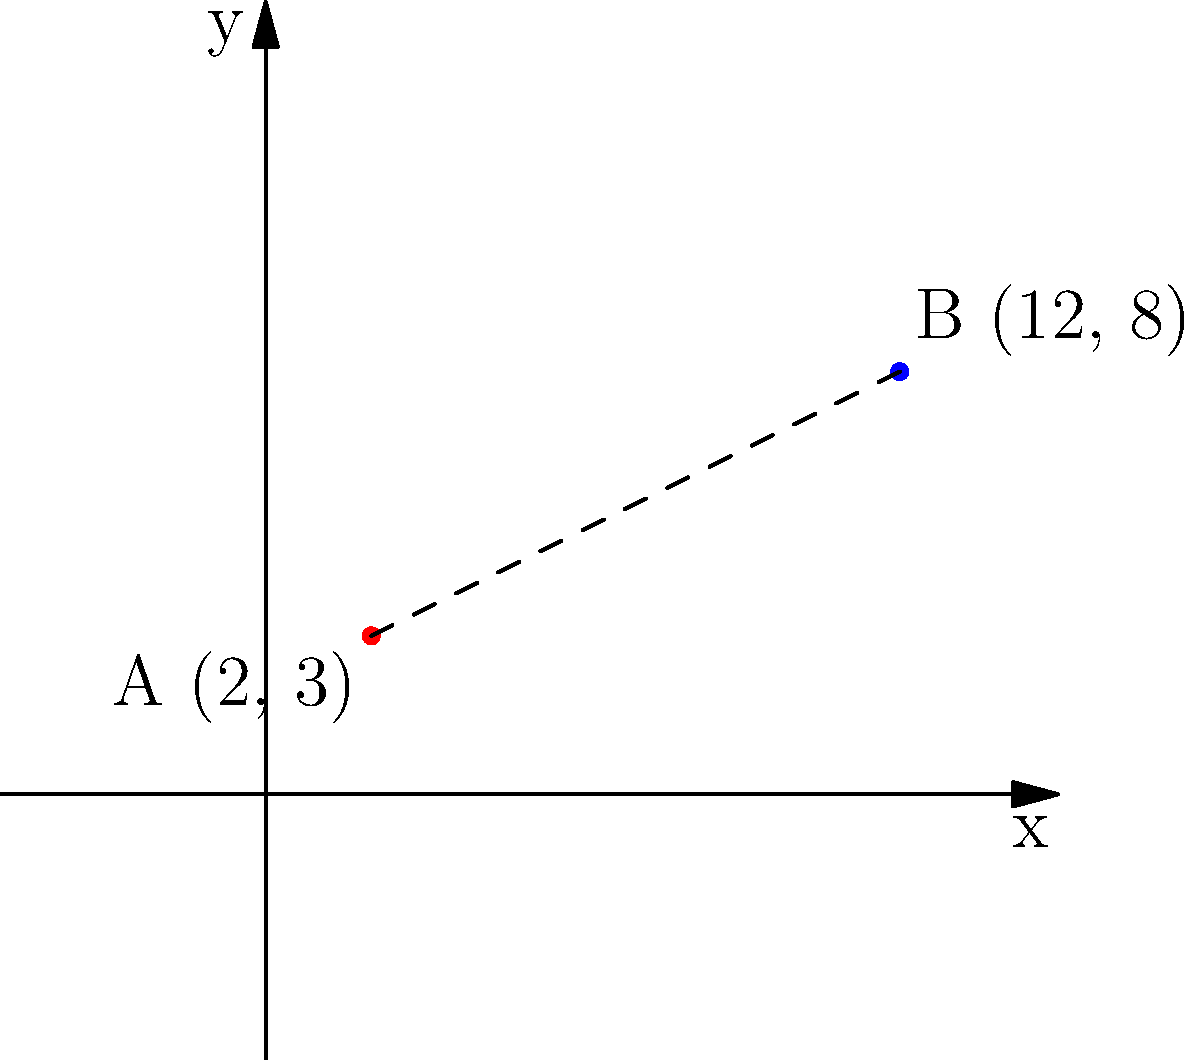As a Node.js developer working on an astronomy application, you need to implement a function to calculate the distance between two celestial bodies. Given the coordinates of two objects in a 2D plane, A(2, 3) and B(12, 8), write a JavaScript function to calculate the distance between them using the distance formula. Round the result to two decimal places. To calculate the distance between two points in a 2D plane, we use the distance formula derived from the Pythagorean theorem:

$$d = \sqrt{(x_2 - x_1)^2 + (y_2 - y_1)^2}$$

Where $(x_1, y_1)$ are the coordinates of the first point and $(x_2, y_2)$ are the coordinates of the second point.

Let's break down the solution step by step:

1. Define the coordinates:
   Point A: $(x_1, y_1) = (2, 3)$
   Point B: $(x_2, y_2) = (12, 8)$

2. Calculate the differences:
   $x_2 - x_1 = 12 - 2 = 10$
   $y_2 - y_1 = 8 - 3 = 5$

3. Square the differences:
   $(x_2 - x_1)^2 = 10^2 = 100$
   $(y_2 - y_1)^2 = 5^2 = 25$

4. Sum the squared differences:
   $(x_2 - x_1)^2 + (y_2 - y_1)^2 = 100 + 25 = 125$

5. Take the square root:
   $d = \sqrt{125} \approx 11.1803398875$

6. Round to two decimal places:
   $d \approx 11.18$

In JavaScript, you can implement this calculation as follows:

```javascript
function calculateDistance(x1, y1, x2, y2) {
  const dx = x2 - x1;
  const dy = y2 - y1;
  const distance = Math.sqrt(dx * dx + dy * dy);
  return Number(distance.toFixed(2));
}

const distance = calculateDistance(2, 3, 12, 8);
console.log(distance); // Output: 11.18
```

This function takes the coordinates of two points as input, calculates the distance using the distance formula, and returns the result rounded to two decimal places.
Answer: 11.18 